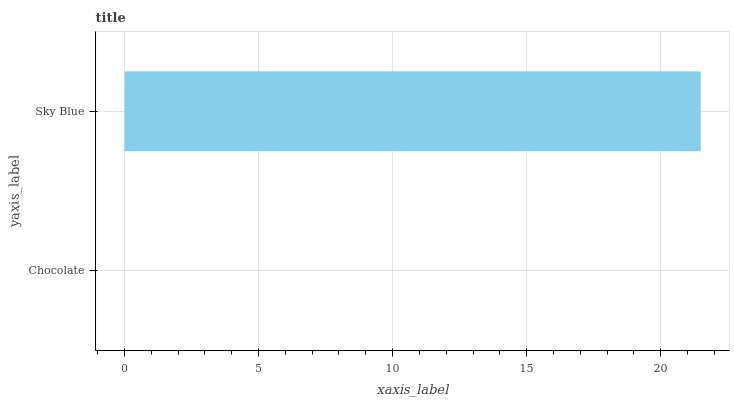Is Chocolate the minimum?
Answer yes or no. Yes. Is Sky Blue the maximum?
Answer yes or no. Yes. Is Sky Blue the minimum?
Answer yes or no. No. Is Sky Blue greater than Chocolate?
Answer yes or no. Yes. Is Chocolate less than Sky Blue?
Answer yes or no. Yes. Is Chocolate greater than Sky Blue?
Answer yes or no. No. Is Sky Blue less than Chocolate?
Answer yes or no. No. Is Sky Blue the high median?
Answer yes or no. Yes. Is Chocolate the low median?
Answer yes or no. Yes. Is Chocolate the high median?
Answer yes or no. No. Is Sky Blue the low median?
Answer yes or no. No. 